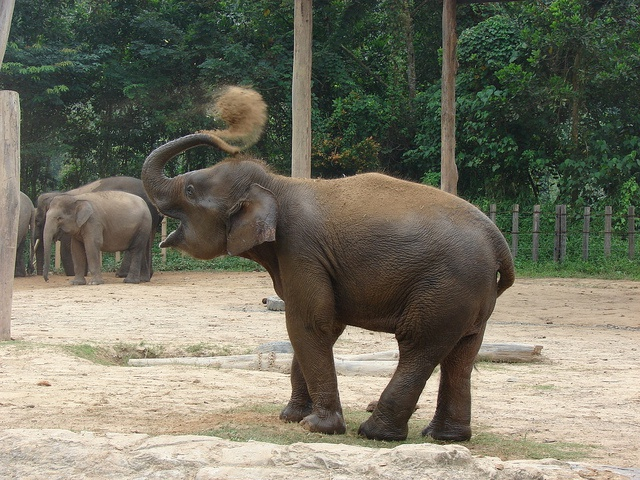Describe the objects in this image and their specific colors. I can see elephant in gray and black tones, elephant in gray, darkgray, and black tones, elephant in gray, darkgray, and black tones, and elephant in gray, darkgray, and black tones in this image. 